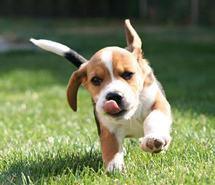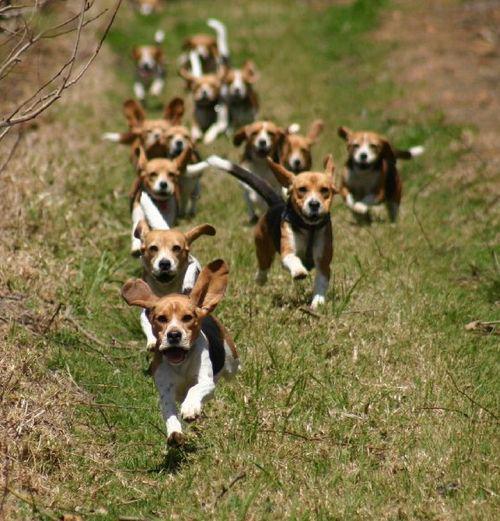The first image is the image on the left, the second image is the image on the right. Given the left and right images, does the statement "Both images in the pair contain only one dog." hold true? Answer yes or no. No. The first image is the image on the left, the second image is the image on the right. For the images displayed, is the sentence "There are no more than two puppies." factually correct? Answer yes or no. No. 